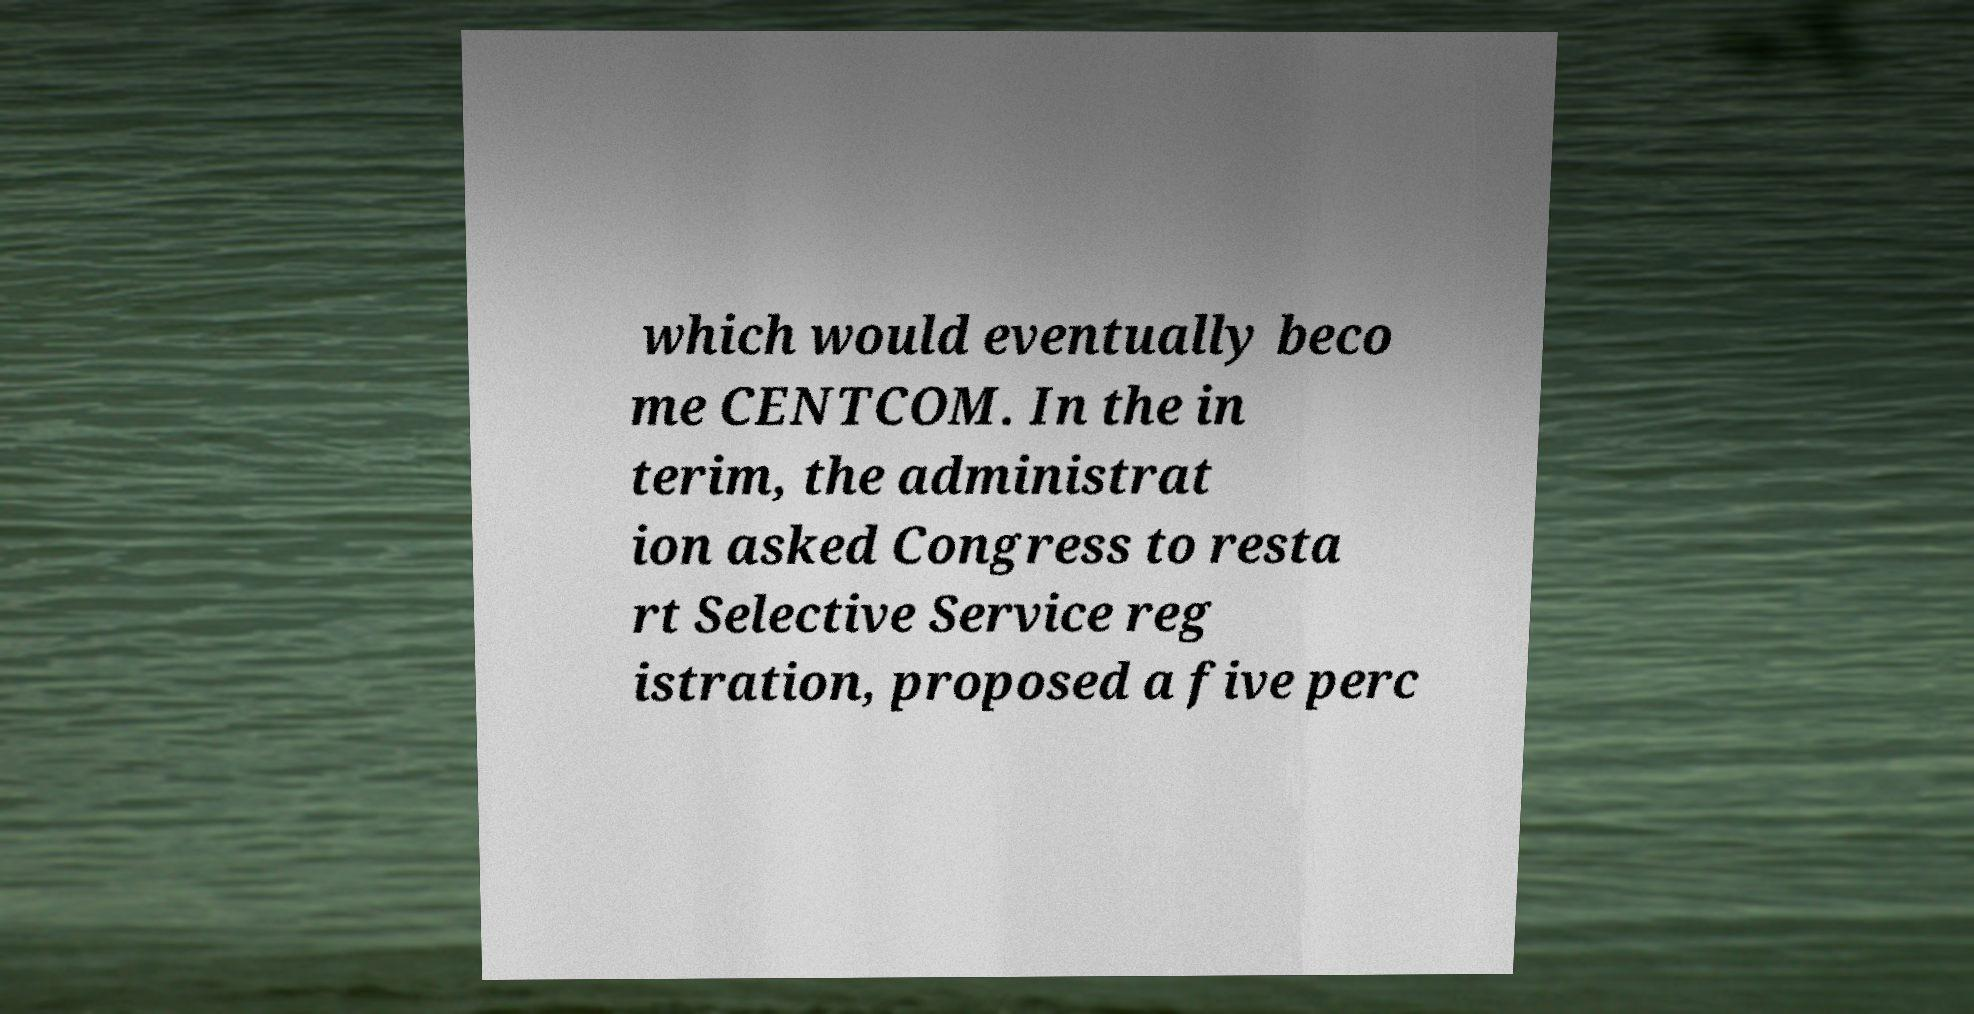There's text embedded in this image that I need extracted. Can you transcribe it verbatim? which would eventually beco me CENTCOM. In the in terim, the administrat ion asked Congress to resta rt Selective Service reg istration, proposed a five perc 